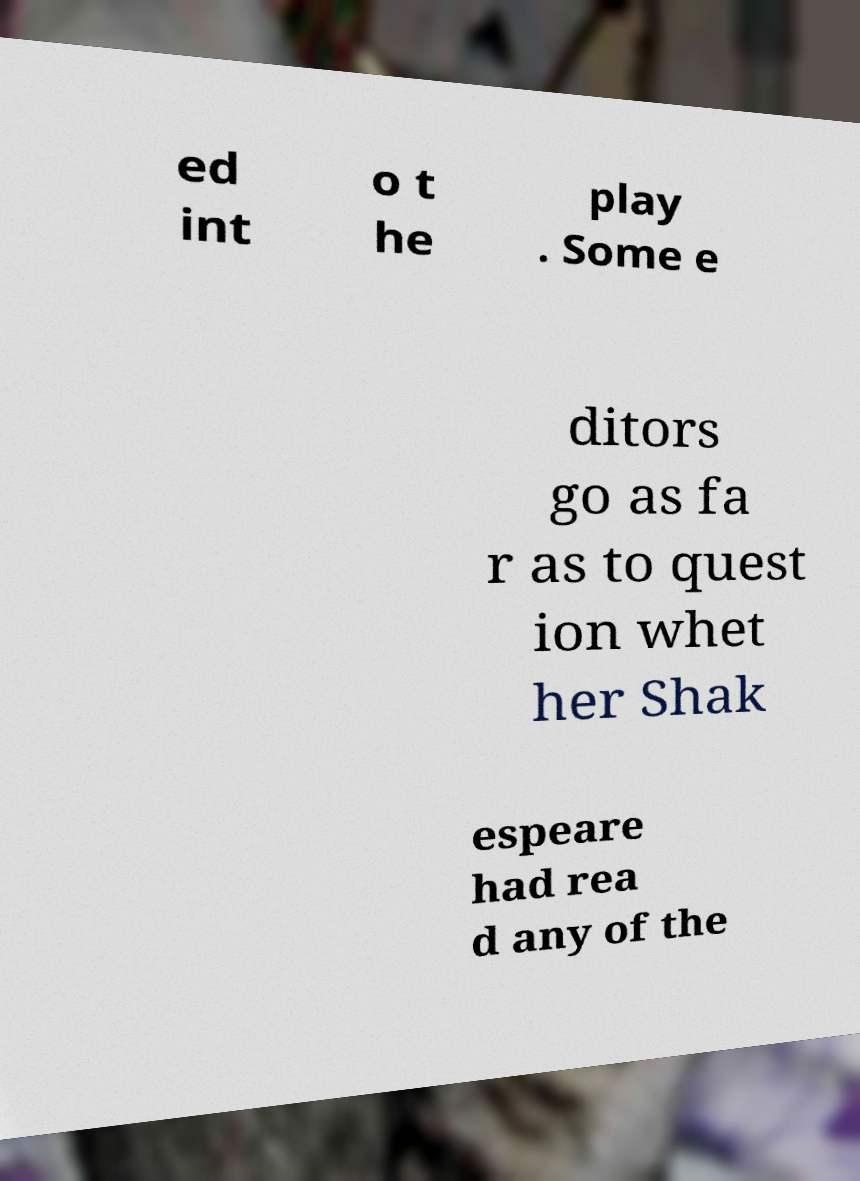Could you assist in decoding the text presented in this image and type it out clearly? ed int o t he play . Some e ditors go as fa r as to quest ion whet her Shak espeare had rea d any of the 